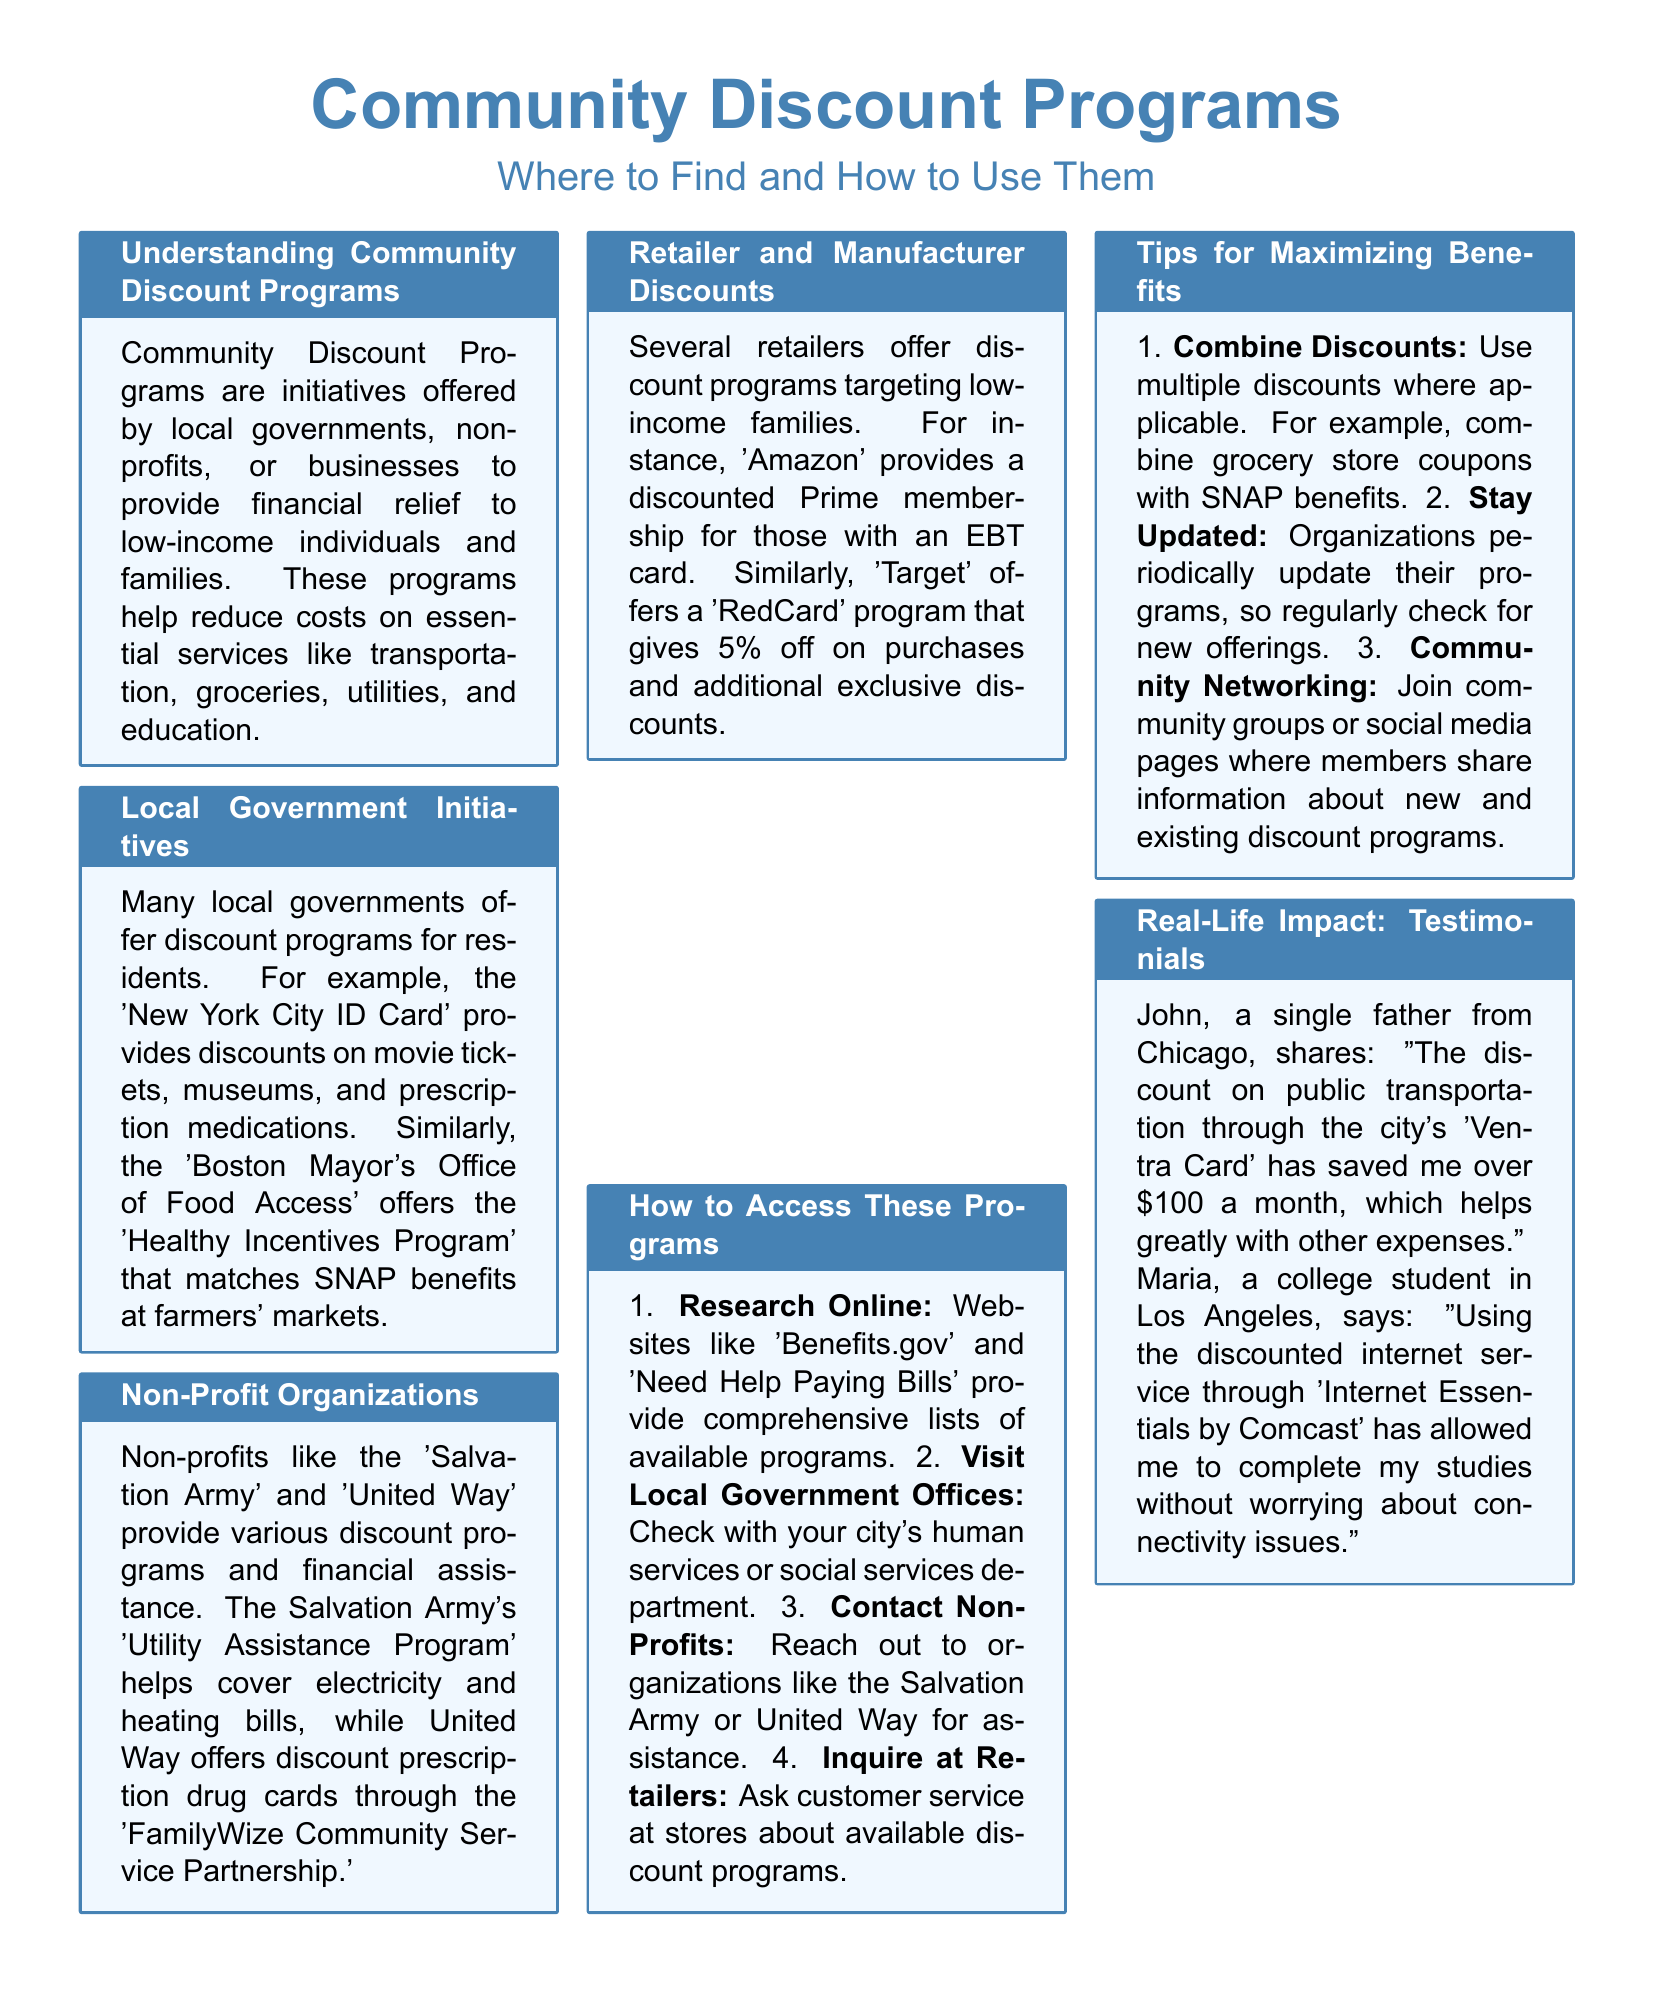what are Community Discount Programs? Community Discount Programs are initiatives offered to provide financial relief to low-income individuals and families on essential services.
Answer: initiatives offered to provide financial relief what program provides discounts on movie tickets? The 'New York City ID Card' provides discounts on movie tickets mentioned in the document.
Answer: New York City ID Card which organization helps cover electricity and heating bills? The 'Salvation Army' helps cover electricity and heating bills through its program.
Answer: Salvation Army what percentage discount does Target's 'RedCard' program offer? The 'RedCard' program gives a 5% discount on purchases at Target.
Answer: 5% how can you access local government initiatives? You can access local government initiatives by visiting local government offices or checking their websites.
Answer: visit local government offices what is one way to maximize benefits from discount programs? One way to maximize benefits from discount programs is to combine discounts where applicable.
Answer: combine discounts who provides internet service discounts mentioned in testimonials? 'Internet Essentials by Comcast' provides discounted internet service mentioned in the testimonials.
Answer: Internet Essentials by Comcast which website provides lists of available programs? 'Benefits.gov' provides comprehensive lists of available programs.
Answer: Benefits.gov how much does John save per month on transportation? John saves over $100 a month on public transportation through the city's program.
Answer: over $100 